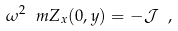Convert formula to latex. <formula><loc_0><loc_0><loc_500><loc_500>\omega ^ { 2 } \ m Z _ { x } ( 0 , y ) = - \mathcal { J } \ ,</formula> 